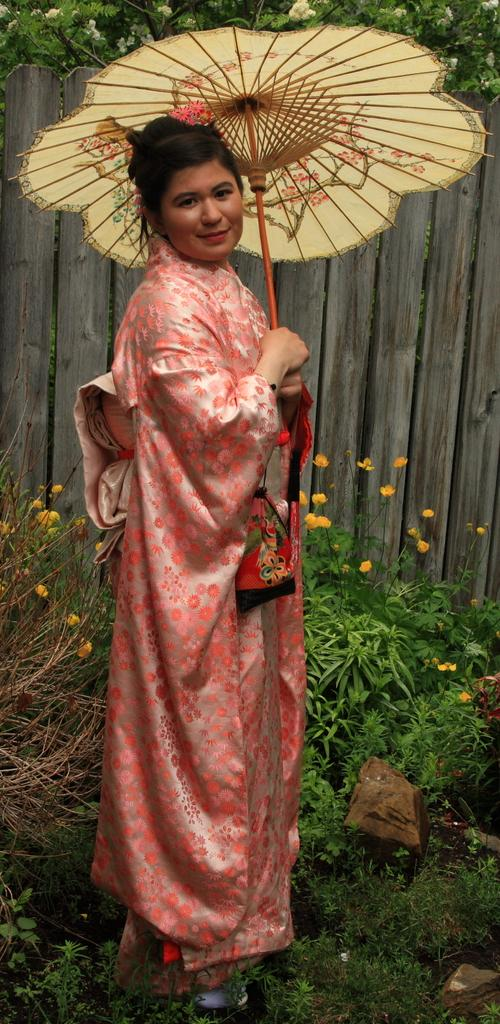What is the woman in the image holding? The woman is holding an umbrella in the image. What type of plants can be seen in the image? There are plants and flowers in the image. What can be found in the background of the image? In the background of the image, there are wooden planks, flowers, and green leaves. What type of flesh can be seen in the image? There is no flesh visible in the image; it primarily features a woman holding an umbrella, plants, flowers, and wooden planks. 